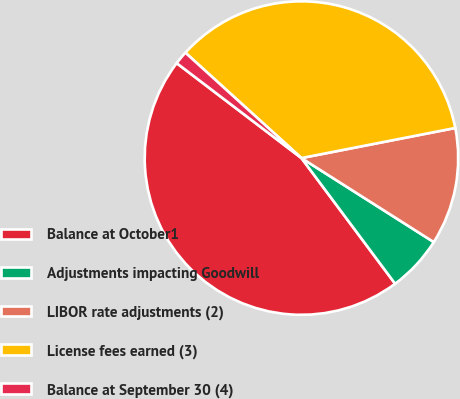<chart> <loc_0><loc_0><loc_500><loc_500><pie_chart><fcel>Balance at October1<fcel>Adjustments impacting Goodwill<fcel>LIBOR rate adjustments (2)<fcel>License fees earned (3)<fcel>Balance at September 30 (4)<nl><fcel>45.55%<fcel>5.8%<fcel>12.08%<fcel>35.2%<fcel>1.38%<nl></chart> 